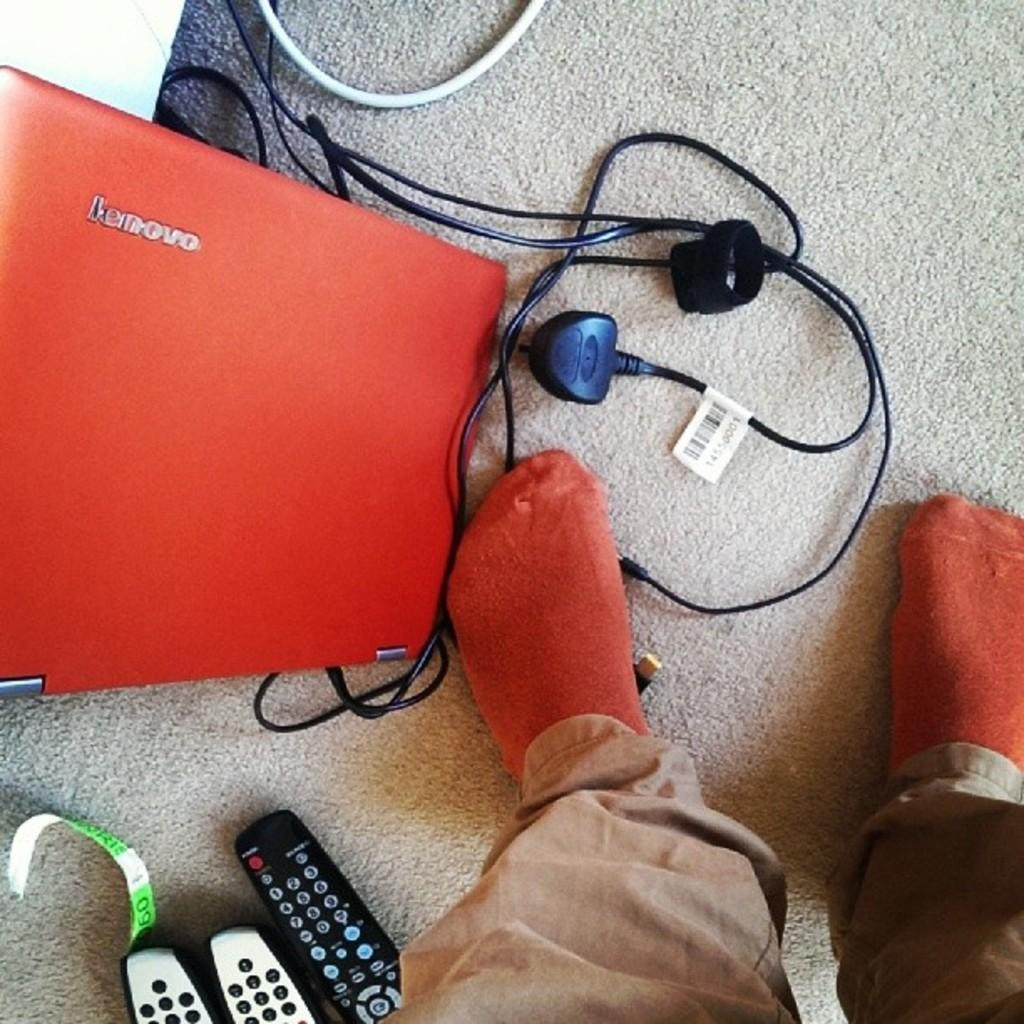What is present in the image? There is a person in the image. What is the person wearing? The person is wearing socks and trousers. What objects can be seen on the floor? There are remotes, a laptop, and wires on the floor. What type of lunchroom is visible in the image? There is no lunchroom present in the image. How many cats can be seen interacting with the laptop in the image? There are no cats present in the image. 